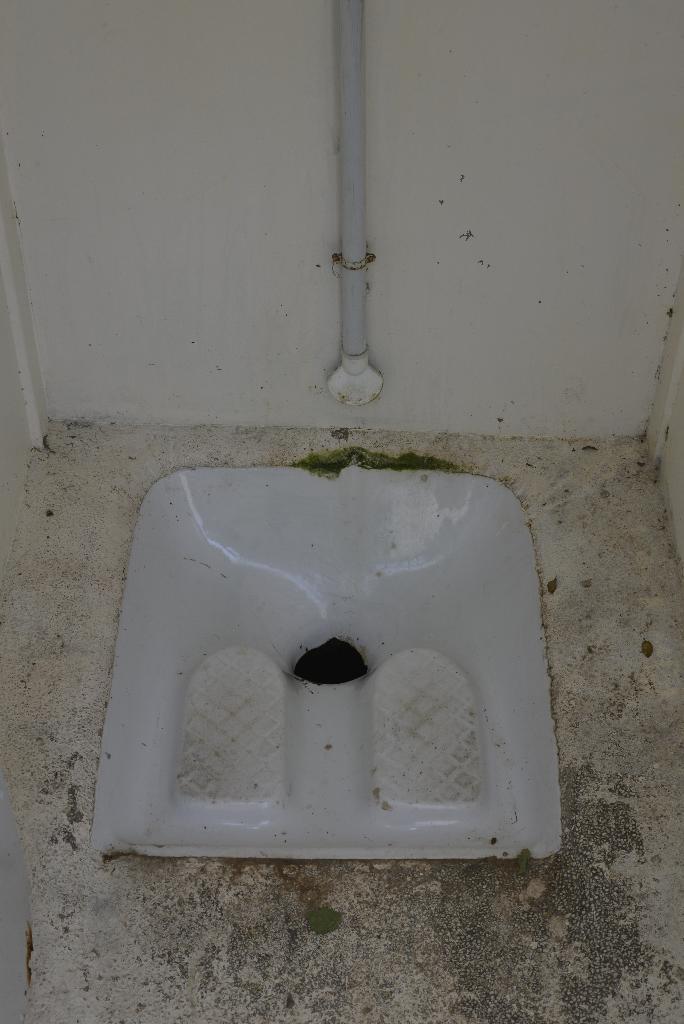Please provide a concise description of this image. It is a washroom and there is a toilet seat,in the background there is a wall and in front of the wall there is a pole attached to the wall. 